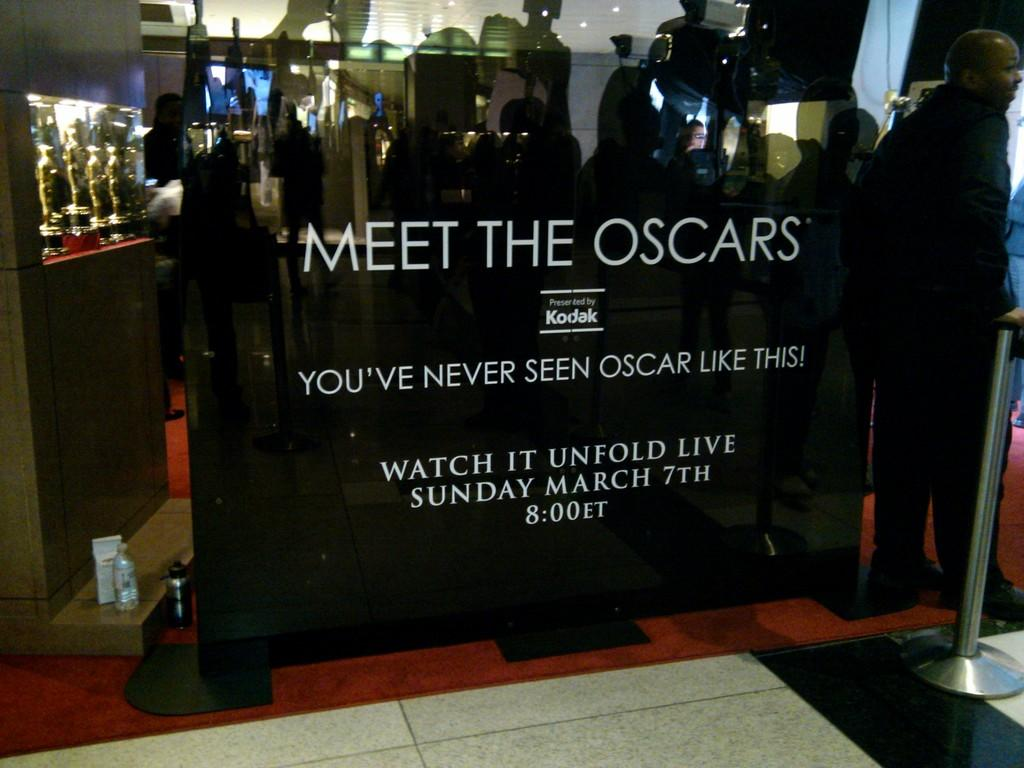What is located in the foreground of the image? There is a banner in the foreground of the image. What can be seen on the left side of the image? There are mementos on the left side of the image. What is present on the right side of the image? There is a person on the right side of the image. What type of object is visible in the image that might serve as a barrier? There is a barrier visible in the image. Can you hear the snakes laughing in the image? There are no snakes or sounds present in the image, so it is not possible to hear them laughing. 